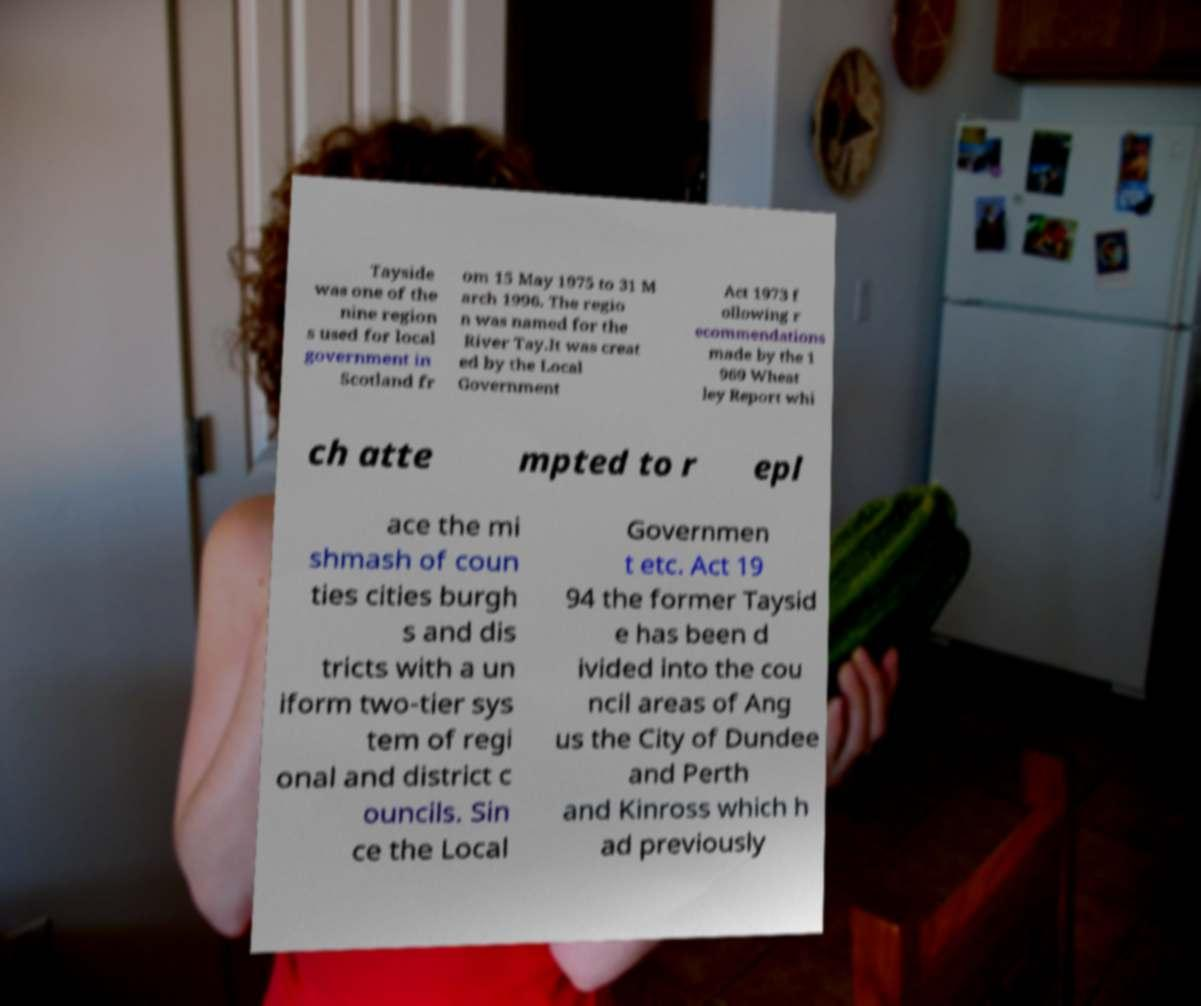Could you assist in decoding the text presented in this image and type it out clearly? Tayside was one of the nine region s used for local government in Scotland fr om 15 May 1975 to 31 M arch 1996. The regio n was named for the River Tay.It was creat ed by the Local Government Act 1973 f ollowing r ecommendations made by the 1 969 Wheat ley Report whi ch atte mpted to r epl ace the mi shmash of coun ties cities burgh s and dis tricts with a un iform two-tier sys tem of regi onal and district c ouncils. Sin ce the Local Governmen t etc. Act 19 94 the former Taysid e has been d ivided into the cou ncil areas of Ang us the City of Dundee and Perth and Kinross which h ad previously 